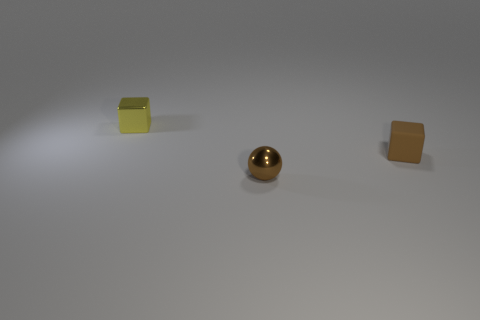Add 1 tiny purple metallic cylinders. How many objects exist? 4 Subtract all blocks. How many objects are left? 1 Add 3 brown rubber cubes. How many brown rubber cubes are left? 4 Add 1 brown metallic things. How many brown metallic things exist? 2 Subtract 0 yellow cylinders. How many objects are left? 3 Subtract all tiny yellow metal blocks. Subtract all big rubber blocks. How many objects are left? 2 